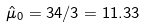<formula> <loc_0><loc_0><loc_500><loc_500>\hat { \mu } _ { 0 } = 3 4 / 3 = 1 1 . 3 3</formula> 